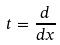<formula> <loc_0><loc_0><loc_500><loc_500>t = \frac { d } { d x }</formula> 